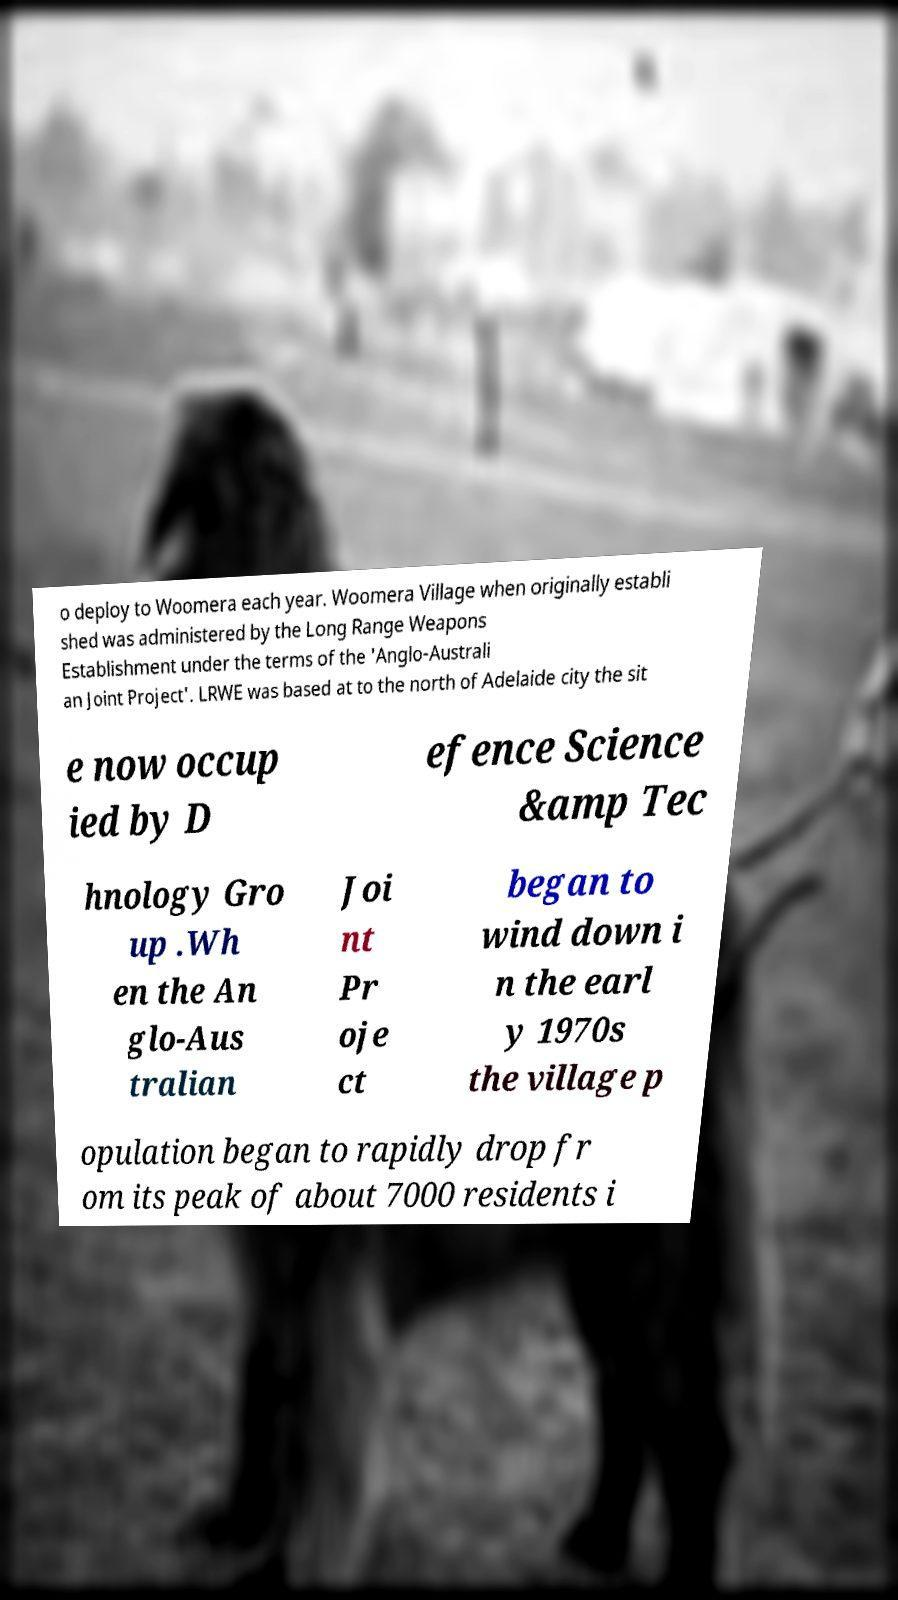Can you accurately transcribe the text from the provided image for me? o deploy to Woomera each year. Woomera Village when originally establi shed was administered by the Long Range Weapons Establishment under the terms of the 'Anglo-Australi an Joint Project'. LRWE was based at to the north of Adelaide city the sit e now occup ied by D efence Science &amp Tec hnology Gro up .Wh en the An glo-Aus tralian Joi nt Pr oje ct began to wind down i n the earl y 1970s the village p opulation began to rapidly drop fr om its peak of about 7000 residents i 